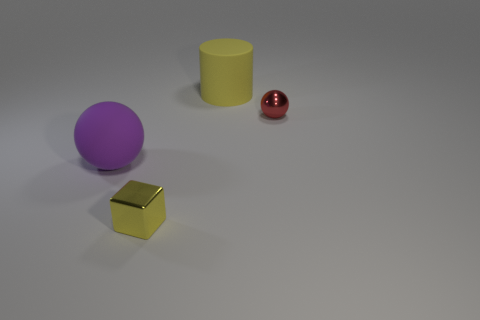There is a object that is behind the tiny cube and left of the yellow rubber object; what material is it made of?
Make the answer very short. Rubber. How many other objects are there of the same color as the small sphere?
Offer a terse response. 0. How many red things are either big rubber objects or small spheres?
Give a very brief answer. 1. There is a purple thing; is its shape the same as the tiny thing that is behind the tiny yellow object?
Offer a very short reply. Yes. What is the shape of the tiny red thing?
Make the answer very short. Sphere. There is a cylinder that is the same size as the purple sphere; what is it made of?
Give a very brief answer. Rubber. How many things are either big cyan rubber cylinders or large yellow rubber things right of the tiny yellow shiny object?
Your response must be concise. 1. What size is the red thing that is the same material as the tiny yellow cube?
Keep it short and to the point. Small. There is a yellow thing behind the large matte object that is on the left side of the tiny shiny cube; what is its shape?
Your answer should be very brief. Cylinder. There is a thing that is both to the right of the purple ball and on the left side of the big yellow matte cylinder; what size is it?
Make the answer very short. Small. 